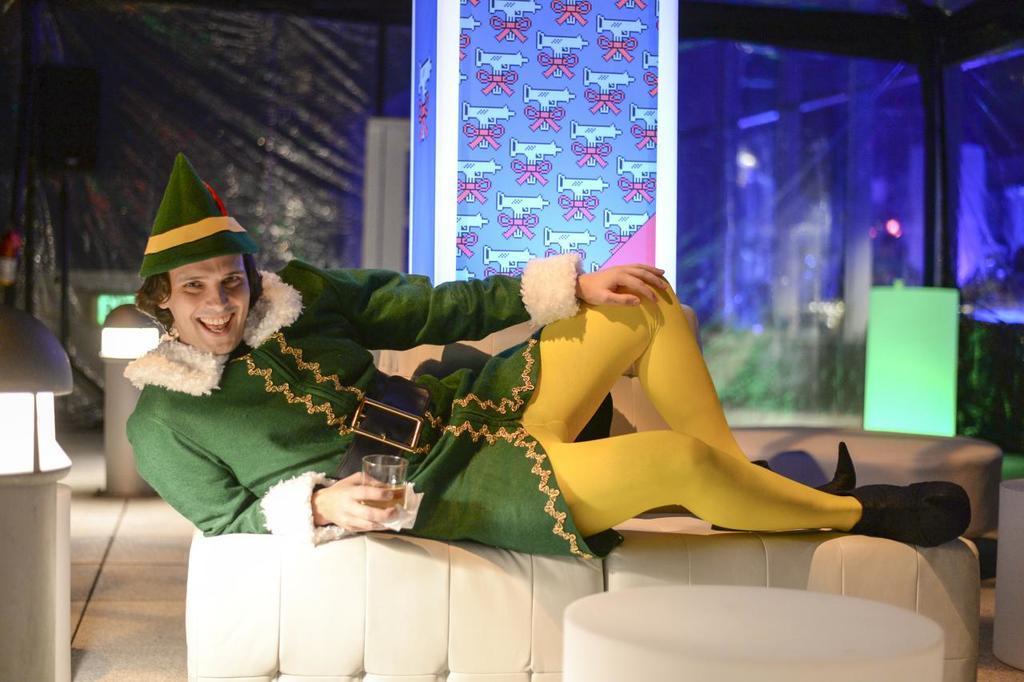Please provide a concise description of this image. In this image we can see a man lying on the sofa and holding a beverage tumbler in the hand. In the background there are electric lights and a curtain. 